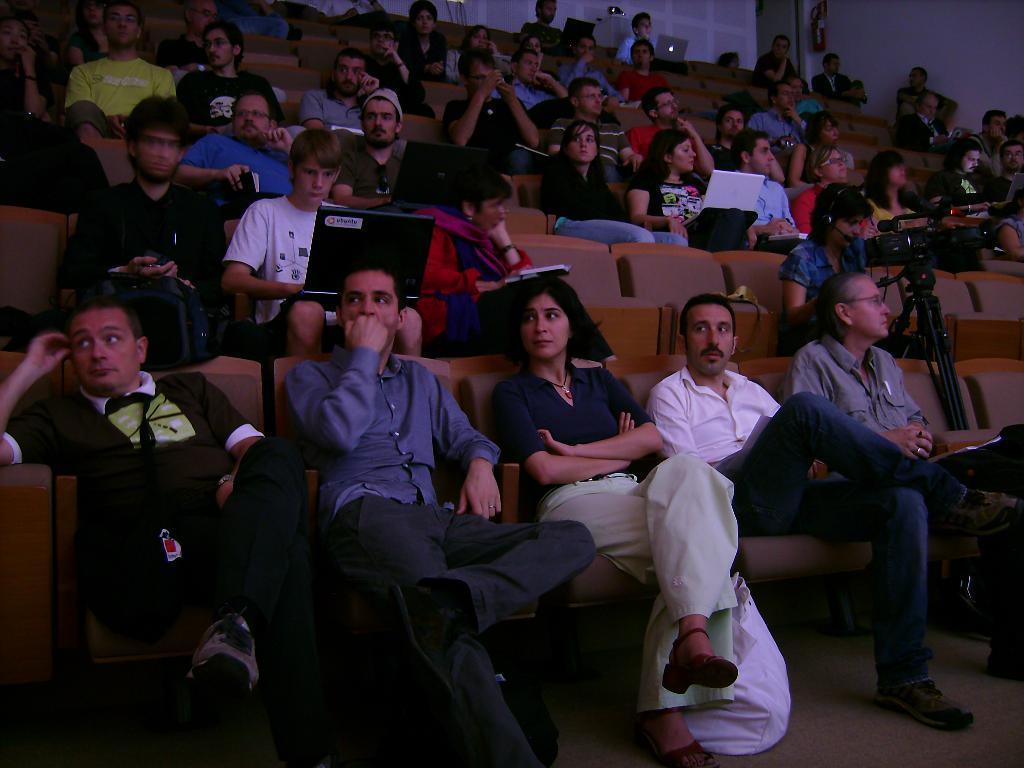Could you give a brief overview of what you see in this image? In this image we can see a group of people sitting on chairs, some people are holding laptops and some devices. One man is holding a book in his hand. On the right side of the image we can see a person holding a camera in his hands. At the bottom of the image we can see a bag placed on the ground. At the top of the image we can see a fire extinguisher on the wall and a door. 